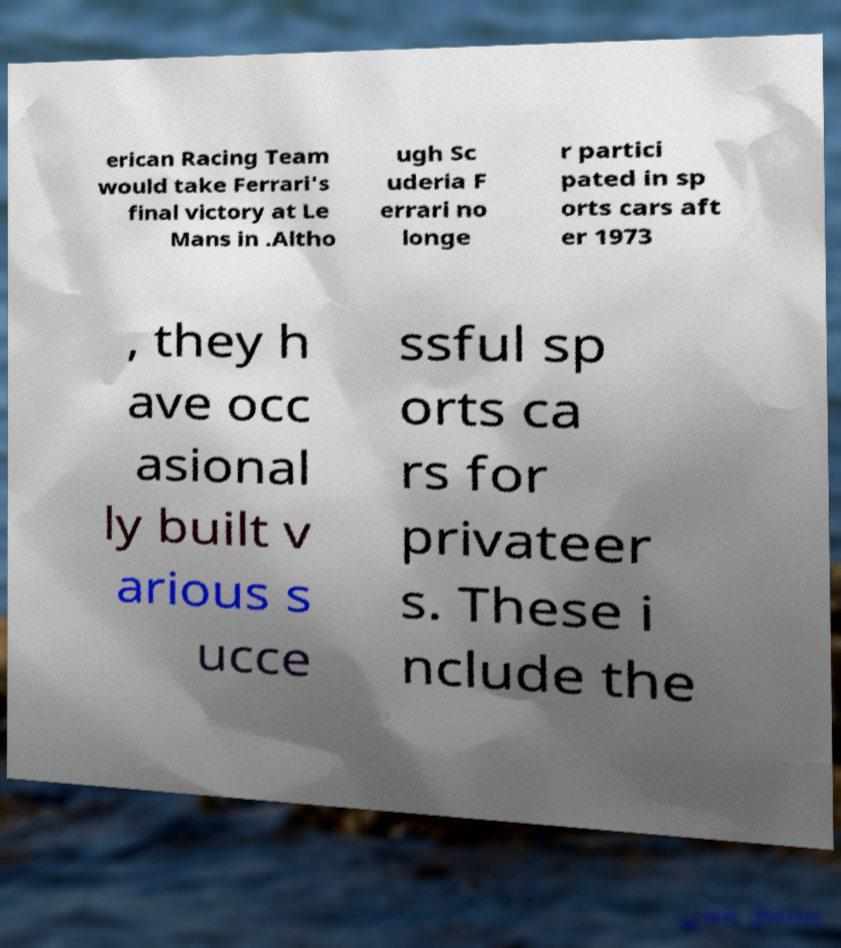Can you read and provide the text displayed in the image?This photo seems to have some interesting text. Can you extract and type it out for me? erican Racing Team would take Ferrari's final victory at Le Mans in .Altho ugh Sc uderia F errari no longe r partici pated in sp orts cars aft er 1973 , they h ave occ asional ly built v arious s ucce ssful sp orts ca rs for privateer s. These i nclude the 